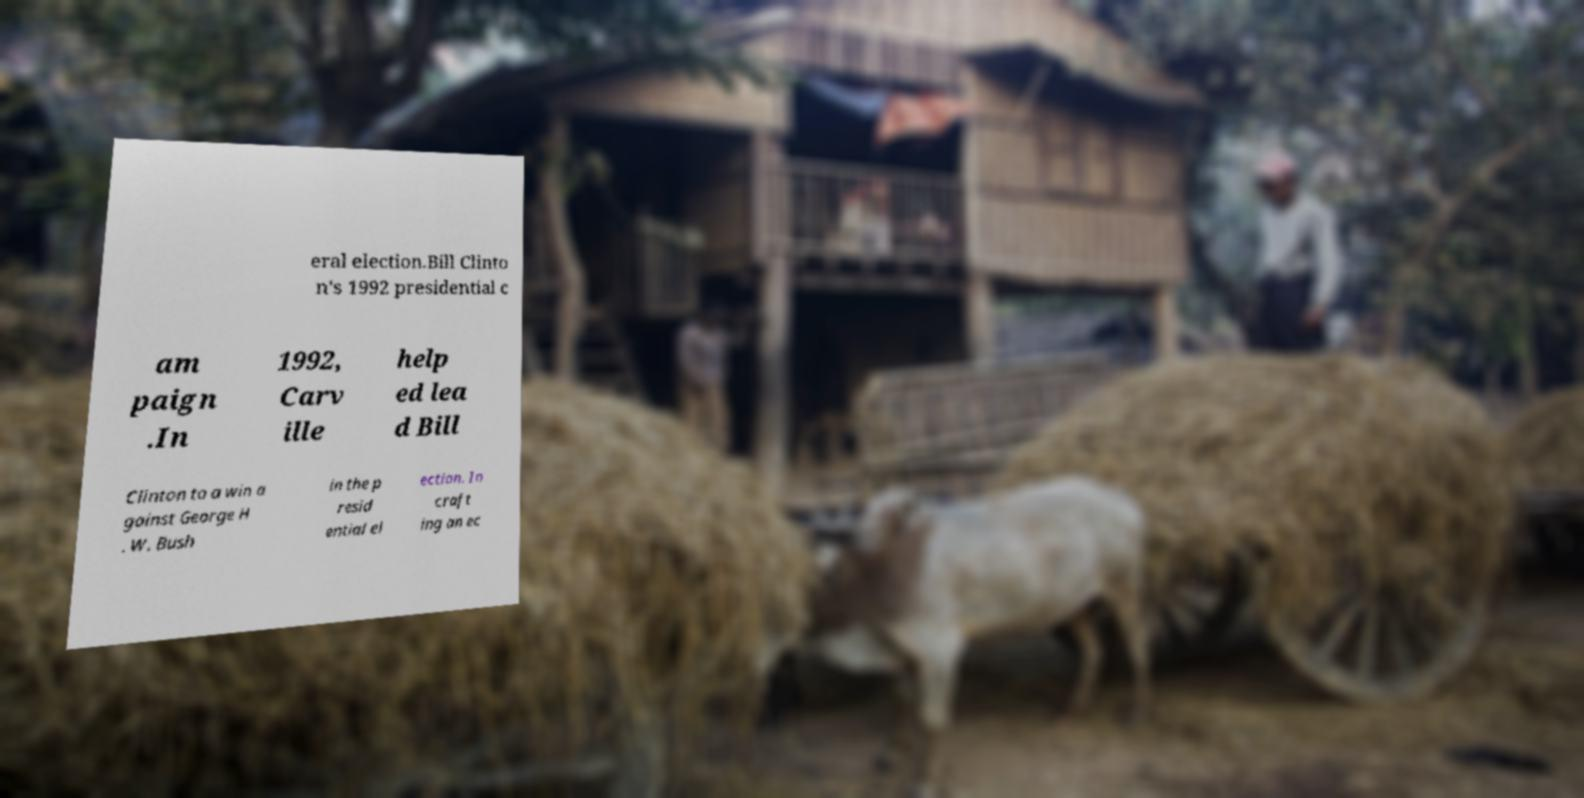Please identify and transcribe the text found in this image. eral election.Bill Clinto n's 1992 presidential c am paign .In 1992, Carv ille help ed lea d Bill Clinton to a win a gainst George H . W. Bush in the p resid ential el ection. In craft ing an ec 